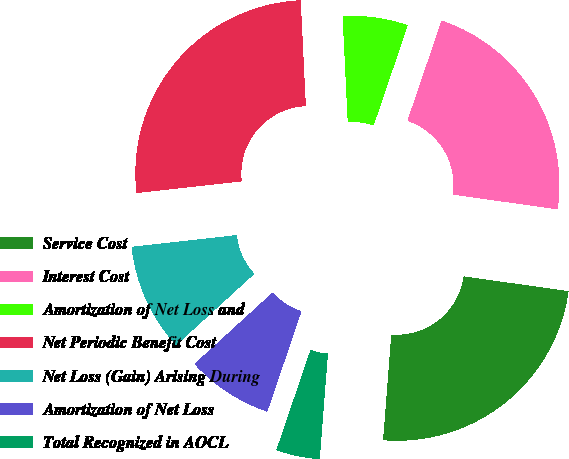Convert chart to OTSL. <chart><loc_0><loc_0><loc_500><loc_500><pie_chart><fcel>Service Cost<fcel>Interest Cost<fcel>Amortization of Net Loss and<fcel>Net Periodic Benefit Cost<fcel>Net Loss (Gain) Arising During<fcel>Amortization of Net Loss<fcel>Total Recognized in AOCL<nl><fcel>24.0%<fcel>22.0%<fcel>6.0%<fcel>26.0%<fcel>10.0%<fcel>8.0%<fcel>4.0%<nl></chart> 